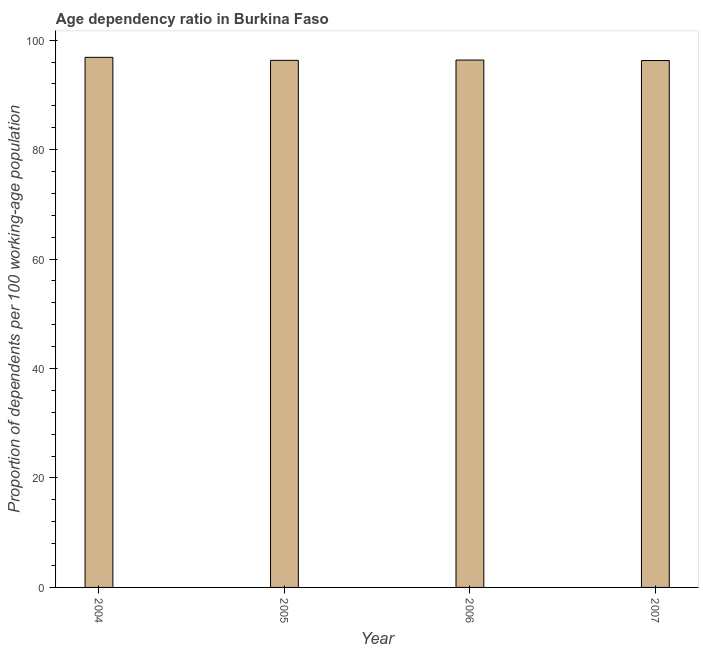Does the graph contain any zero values?
Offer a very short reply. No. What is the title of the graph?
Provide a short and direct response. Age dependency ratio in Burkina Faso. What is the label or title of the Y-axis?
Your answer should be very brief. Proportion of dependents per 100 working-age population. What is the age dependency ratio in 2005?
Make the answer very short. 96.32. Across all years, what is the maximum age dependency ratio?
Offer a very short reply. 96.87. Across all years, what is the minimum age dependency ratio?
Offer a terse response. 96.28. What is the sum of the age dependency ratio?
Your response must be concise. 385.83. What is the difference between the age dependency ratio in 2004 and 2007?
Provide a succinct answer. 0.59. What is the average age dependency ratio per year?
Your answer should be compact. 96.46. What is the median age dependency ratio?
Make the answer very short. 96.34. In how many years, is the age dependency ratio greater than 28 ?
Your answer should be compact. 4. Do a majority of the years between 2007 and 2004 (inclusive) have age dependency ratio greater than 48 ?
Your answer should be compact. Yes. What is the ratio of the age dependency ratio in 2004 to that in 2005?
Your answer should be very brief. 1.01. What is the difference between the highest and the second highest age dependency ratio?
Keep it short and to the point. 0.5. Is the sum of the age dependency ratio in 2004 and 2007 greater than the maximum age dependency ratio across all years?
Provide a short and direct response. Yes. What is the difference between the highest and the lowest age dependency ratio?
Your response must be concise. 0.59. What is the Proportion of dependents per 100 working-age population in 2004?
Your answer should be compact. 96.87. What is the Proportion of dependents per 100 working-age population in 2005?
Offer a terse response. 96.32. What is the Proportion of dependents per 100 working-age population in 2006?
Give a very brief answer. 96.37. What is the Proportion of dependents per 100 working-age population of 2007?
Offer a very short reply. 96.28. What is the difference between the Proportion of dependents per 100 working-age population in 2004 and 2005?
Your answer should be very brief. 0.55. What is the difference between the Proportion of dependents per 100 working-age population in 2004 and 2006?
Provide a short and direct response. 0.5. What is the difference between the Proportion of dependents per 100 working-age population in 2004 and 2007?
Make the answer very short. 0.59. What is the difference between the Proportion of dependents per 100 working-age population in 2005 and 2006?
Provide a short and direct response. -0.05. What is the difference between the Proportion of dependents per 100 working-age population in 2005 and 2007?
Provide a succinct answer. 0.04. What is the difference between the Proportion of dependents per 100 working-age population in 2006 and 2007?
Give a very brief answer. 0.09. What is the ratio of the Proportion of dependents per 100 working-age population in 2004 to that in 2006?
Offer a very short reply. 1. What is the ratio of the Proportion of dependents per 100 working-age population in 2006 to that in 2007?
Provide a succinct answer. 1. 